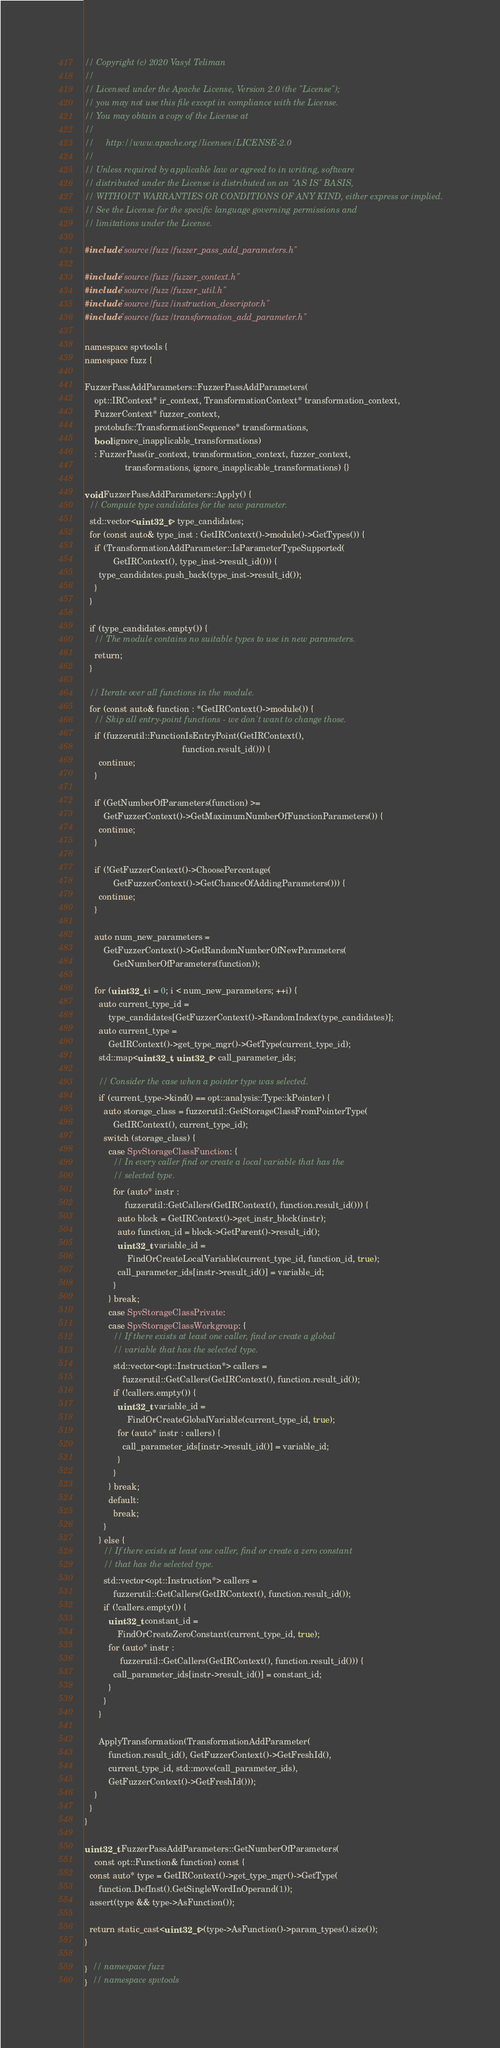<code> <loc_0><loc_0><loc_500><loc_500><_C++_>// Copyright (c) 2020 Vasyl Teliman
//
// Licensed under the Apache License, Version 2.0 (the "License");
// you may not use this file except in compliance with the License.
// You may obtain a copy of the License at
//
//     http://www.apache.org/licenses/LICENSE-2.0
//
// Unless required by applicable law or agreed to in writing, software
// distributed under the License is distributed on an "AS IS" BASIS,
// WITHOUT WARRANTIES OR CONDITIONS OF ANY KIND, either express or implied.
// See the License for the specific language governing permissions and
// limitations under the License.

#include "source/fuzz/fuzzer_pass_add_parameters.h"

#include "source/fuzz/fuzzer_context.h"
#include "source/fuzz/fuzzer_util.h"
#include "source/fuzz/instruction_descriptor.h"
#include "source/fuzz/transformation_add_parameter.h"

namespace spvtools {
namespace fuzz {

FuzzerPassAddParameters::FuzzerPassAddParameters(
    opt::IRContext* ir_context, TransformationContext* transformation_context,
    FuzzerContext* fuzzer_context,
    protobufs::TransformationSequence* transformations,
    bool ignore_inapplicable_transformations)
    : FuzzerPass(ir_context, transformation_context, fuzzer_context,
                 transformations, ignore_inapplicable_transformations) {}

void FuzzerPassAddParameters::Apply() {
  // Compute type candidates for the new parameter.
  std::vector<uint32_t> type_candidates;
  for (const auto& type_inst : GetIRContext()->module()->GetTypes()) {
    if (TransformationAddParameter::IsParameterTypeSupported(
            GetIRContext(), type_inst->result_id())) {
      type_candidates.push_back(type_inst->result_id());
    }
  }

  if (type_candidates.empty()) {
    // The module contains no suitable types to use in new parameters.
    return;
  }

  // Iterate over all functions in the module.
  for (const auto& function : *GetIRContext()->module()) {
    // Skip all entry-point functions - we don't want to change those.
    if (fuzzerutil::FunctionIsEntryPoint(GetIRContext(),
                                         function.result_id())) {
      continue;
    }

    if (GetNumberOfParameters(function) >=
        GetFuzzerContext()->GetMaximumNumberOfFunctionParameters()) {
      continue;
    }

    if (!GetFuzzerContext()->ChoosePercentage(
            GetFuzzerContext()->GetChanceOfAddingParameters())) {
      continue;
    }

    auto num_new_parameters =
        GetFuzzerContext()->GetRandomNumberOfNewParameters(
            GetNumberOfParameters(function));

    for (uint32_t i = 0; i < num_new_parameters; ++i) {
      auto current_type_id =
          type_candidates[GetFuzzerContext()->RandomIndex(type_candidates)];
      auto current_type =
          GetIRContext()->get_type_mgr()->GetType(current_type_id);
      std::map<uint32_t, uint32_t> call_parameter_ids;

      // Consider the case when a pointer type was selected.
      if (current_type->kind() == opt::analysis::Type::kPointer) {
        auto storage_class = fuzzerutil::GetStorageClassFromPointerType(
            GetIRContext(), current_type_id);
        switch (storage_class) {
          case SpvStorageClassFunction: {
            // In every caller find or create a local variable that has the
            // selected type.
            for (auto* instr :
                 fuzzerutil::GetCallers(GetIRContext(), function.result_id())) {
              auto block = GetIRContext()->get_instr_block(instr);
              auto function_id = block->GetParent()->result_id();
              uint32_t variable_id =
                  FindOrCreateLocalVariable(current_type_id, function_id, true);
              call_parameter_ids[instr->result_id()] = variable_id;
            }
          } break;
          case SpvStorageClassPrivate:
          case SpvStorageClassWorkgroup: {
            // If there exists at least one caller, find or create a global
            // variable that has the selected type.
            std::vector<opt::Instruction*> callers =
                fuzzerutil::GetCallers(GetIRContext(), function.result_id());
            if (!callers.empty()) {
              uint32_t variable_id =
                  FindOrCreateGlobalVariable(current_type_id, true);
              for (auto* instr : callers) {
                call_parameter_ids[instr->result_id()] = variable_id;
              }
            }
          } break;
          default:
            break;
        }
      } else {
        // If there exists at least one caller, find or create a zero constant
        // that has the selected type.
        std::vector<opt::Instruction*> callers =
            fuzzerutil::GetCallers(GetIRContext(), function.result_id());
        if (!callers.empty()) {
          uint32_t constant_id =
              FindOrCreateZeroConstant(current_type_id, true);
          for (auto* instr :
               fuzzerutil::GetCallers(GetIRContext(), function.result_id())) {
            call_parameter_ids[instr->result_id()] = constant_id;
          }
        }
      }

      ApplyTransformation(TransformationAddParameter(
          function.result_id(), GetFuzzerContext()->GetFreshId(),
          current_type_id, std::move(call_parameter_ids),
          GetFuzzerContext()->GetFreshId()));
    }
  }
}

uint32_t FuzzerPassAddParameters::GetNumberOfParameters(
    const opt::Function& function) const {
  const auto* type = GetIRContext()->get_type_mgr()->GetType(
      function.DefInst().GetSingleWordInOperand(1));
  assert(type && type->AsFunction());

  return static_cast<uint32_t>(type->AsFunction()->param_types().size());
}

}  // namespace fuzz
}  // namespace spvtools
</code> 